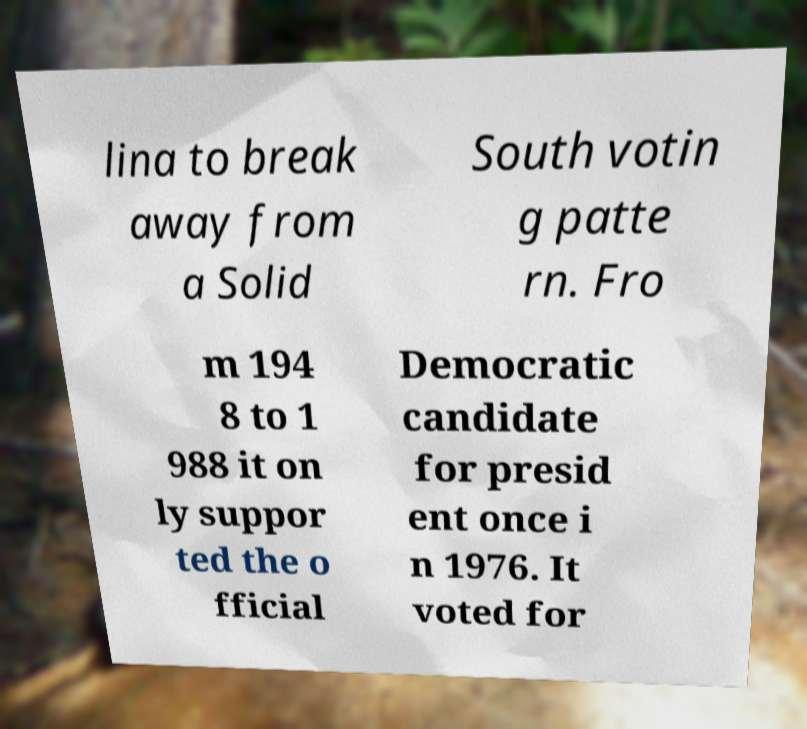I need the written content from this picture converted into text. Can you do that? lina to break away from a Solid South votin g patte rn. Fro m 194 8 to 1 988 it on ly suppor ted the o fficial Democratic candidate for presid ent once i n 1976. It voted for 